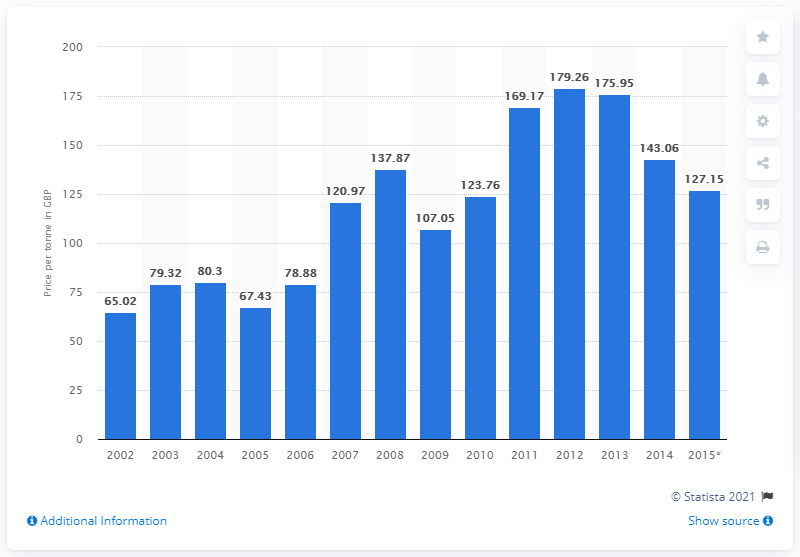Outline some significant characteristics in this image. In 2012, the price per tonne of wheat was 179.26. 